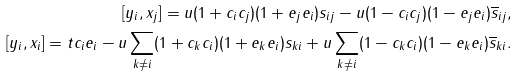<formula> <loc_0><loc_0><loc_500><loc_500>[ y _ { i } , x _ { j } ] = u ( 1 + c _ { i } c _ { j } ) ( 1 + e _ { j } e _ { i } ) s _ { i j } - u ( 1 - c _ { i } c _ { j } ) ( 1 - e _ { j } e _ { i } ) \overline { s } _ { i j } , \\ [ y _ { i } , x _ { i } ] = t c _ { i } e _ { i } - u \sum _ { k \neq i } ( 1 + c _ { k } c _ { i } ) ( 1 + e _ { k } e _ { i } ) s _ { k i } + u \sum _ { k \neq i } ( 1 - c _ { k } c _ { i } ) ( 1 - e _ { k } e _ { i } ) \overline { s } _ { k i } .</formula> 